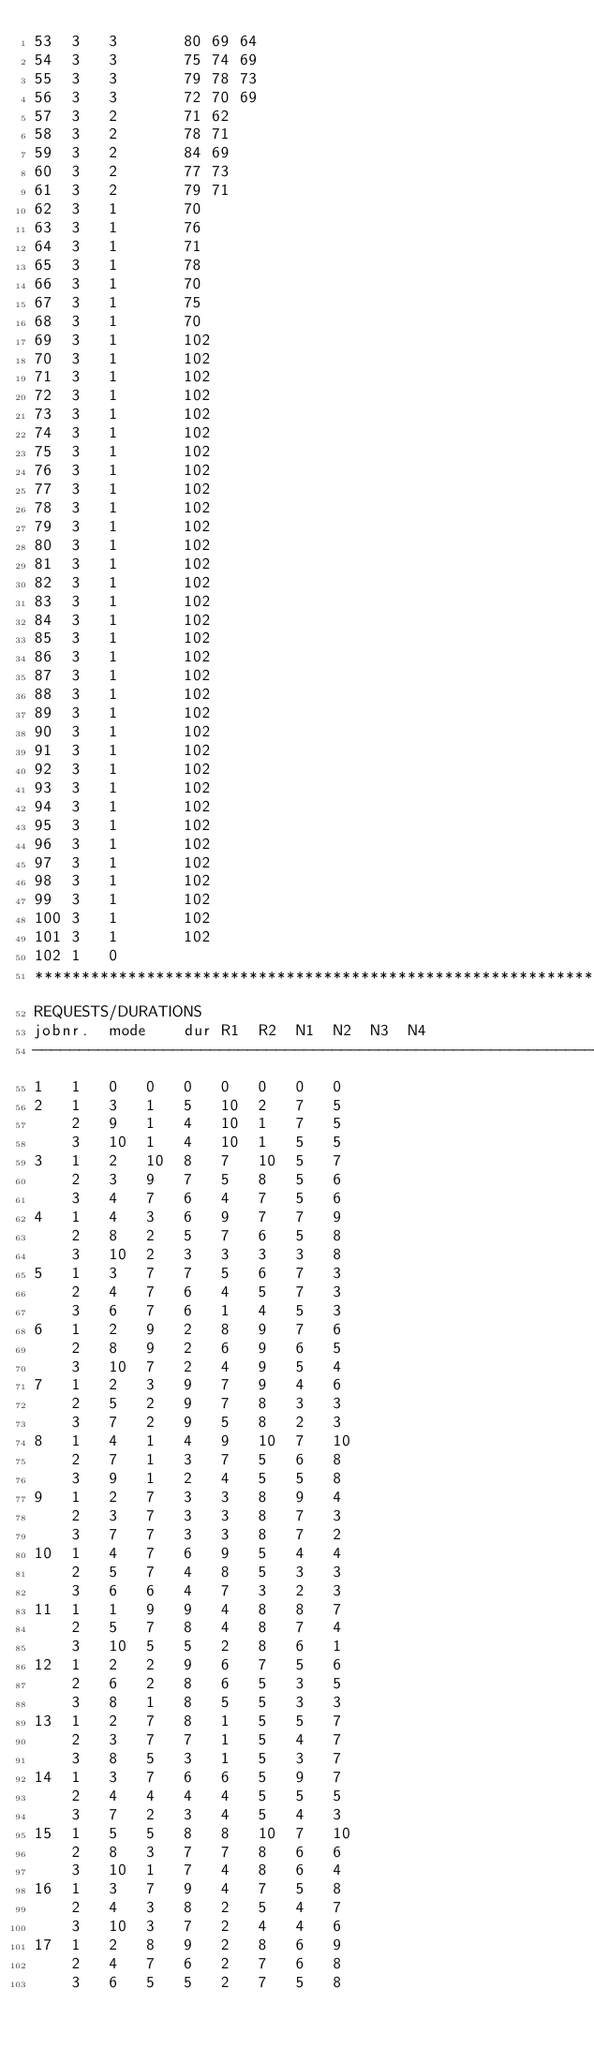Convert code to text. <code><loc_0><loc_0><loc_500><loc_500><_ObjectiveC_>53	3	3		80 69 64 
54	3	3		75 74 69 
55	3	3		79 78 73 
56	3	3		72 70 69 
57	3	2		71 62 
58	3	2		78 71 
59	3	2		84 69 
60	3	2		77 73 
61	3	2		79 71 
62	3	1		70 
63	3	1		76 
64	3	1		71 
65	3	1		78 
66	3	1		70 
67	3	1		75 
68	3	1		70 
69	3	1		102 
70	3	1		102 
71	3	1		102 
72	3	1		102 
73	3	1		102 
74	3	1		102 
75	3	1		102 
76	3	1		102 
77	3	1		102 
78	3	1		102 
79	3	1		102 
80	3	1		102 
81	3	1		102 
82	3	1		102 
83	3	1		102 
84	3	1		102 
85	3	1		102 
86	3	1		102 
87	3	1		102 
88	3	1		102 
89	3	1		102 
90	3	1		102 
91	3	1		102 
92	3	1		102 
93	3	1		102 
94	3	1		102 
95	3	1		102 
96	3	1		102 
97	3	1		102 
98	3	1		102 
99	3	1		102 
100	3	1		102 
101	3	1		102 
102	1	0		
************************************************************************
REQUESTS/DURATIONS
jobnr.	mode	dur	R1	R2	N1	N2	N3	N4	
------------------------------------------------------------------------
1	1	0	0	0	0	0	0	0	
2	1	3	1	5	10	2	7	5	
	2	9	1	4	10	1	7	5	
	3	10	1	4	10	1	5	5	
3	1	2	10	8	7	10	5	7	
	2	3	9	7	5	8	5	6	
	3	4	7	6	4	7	5	6	
4	1	4	3	6	9	7	7	9	
	2	8	2	5	7	6	5	8	
	3	10	2	3	3	3	3	8	
5	1	3	7	7	5	6	7	3	
	2	4	7	6	4	5	7	3	
	3	6	7	6	1	4	5	3	
6	1	2	9	2	8	9	7	6	
	2	8	9	2	6	9	6	5	
	3	10	7	2	4	9	5	4	
7	1	2	3	9	7	9	4	6	
	2	5	2	9	7	8	3	3	
	3	7	2	9	5	8	2	3	
8	1	4	1	4	9	10	7	10	
	2	7	1	3	7	5	6	8	
	3	9	1	2	4	5	5	8	
9	1	2	7	3	3	8	9	4	
	2	3	7	3	3	8	7	3	
	3	7	7	3	3	8	7	2	
10	1	4	7	6	9	5	4	4	
	2	5	7	4	8	5	3	3	
	3	6	6	4	7	3	2	3	
11	1	1	9	9	4	8	8	7	
	2	5	7	8	4	8	7	4	
	3	10	5	5	2	8	6	1	
12	1	2	2	9	6	7	5	6	
	2	6	2	8	6	5	3	5	
	3	8	1	8	5	5	3	3	
13	1	2	7	8	1	5	5	7	
	2	3	7	7	1	5	4	7	
	3	8	5	3	1	5	3	7	
14	1	3	7	6	6	5	9	7	
	2	4	4	4	4	5	5	5	
	3	7	2	3	4	5	4	3	
15	1	5	5	8	8	10	7	10	
	2	8	3	7	7	8	6	6	
	3	10	1	7	4	8	6	4	
16	1	3	7	9	4	7	5	8	
	2	4	3	8	2	5	4	7	
	3	10	3	7	2	4	4	6	
17	1	2	8	9	2	8	6	9	
	2	4	7	6	2	7	6	8	
	3	6	5	5	2	7	5	8	</code> 